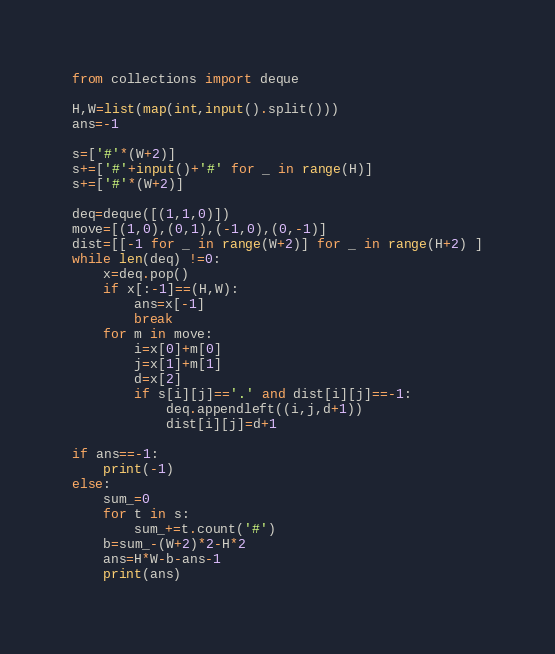Convert code to text. <code><loc_0><loc_0><loc_500><loc_500><_Python_>from collections import deque

H,W=list(map(int,input().split()))
ans=-1

s=['#'*(W+2)]
s+=['#'+input()+'#' for _ in range(H)]
s+=['#'*(W+2)]

deq=deque([(1,1,0)])
move=[(1,0),(0,1),(-1,0),(0,-1)]
dist=[[-1 for _ in range(W+2)] for _ in range(H+2) ]
while len(deq) !=0:
    x=deq.pop()
    if x[:-1]==(H,W):
        ans=x[-1]
        break
    for m in move:
        i=x[0]+m[0]
        j=x[1]+m[1]
        d=x[2]
        if s[i][j]=='.' and dist[i][j]==-1:
            deq.appendleft((i,j,d+1))
            dist[i][j]=d+1

if ans==-1:
    print(-1)
else:
    sum_=0
    for t in s:
        sum_+=t.count('#')
    b=sum_-(W+2)*2-H*2
    ans=H*W-b-ans-1
    print(ans)</code> 